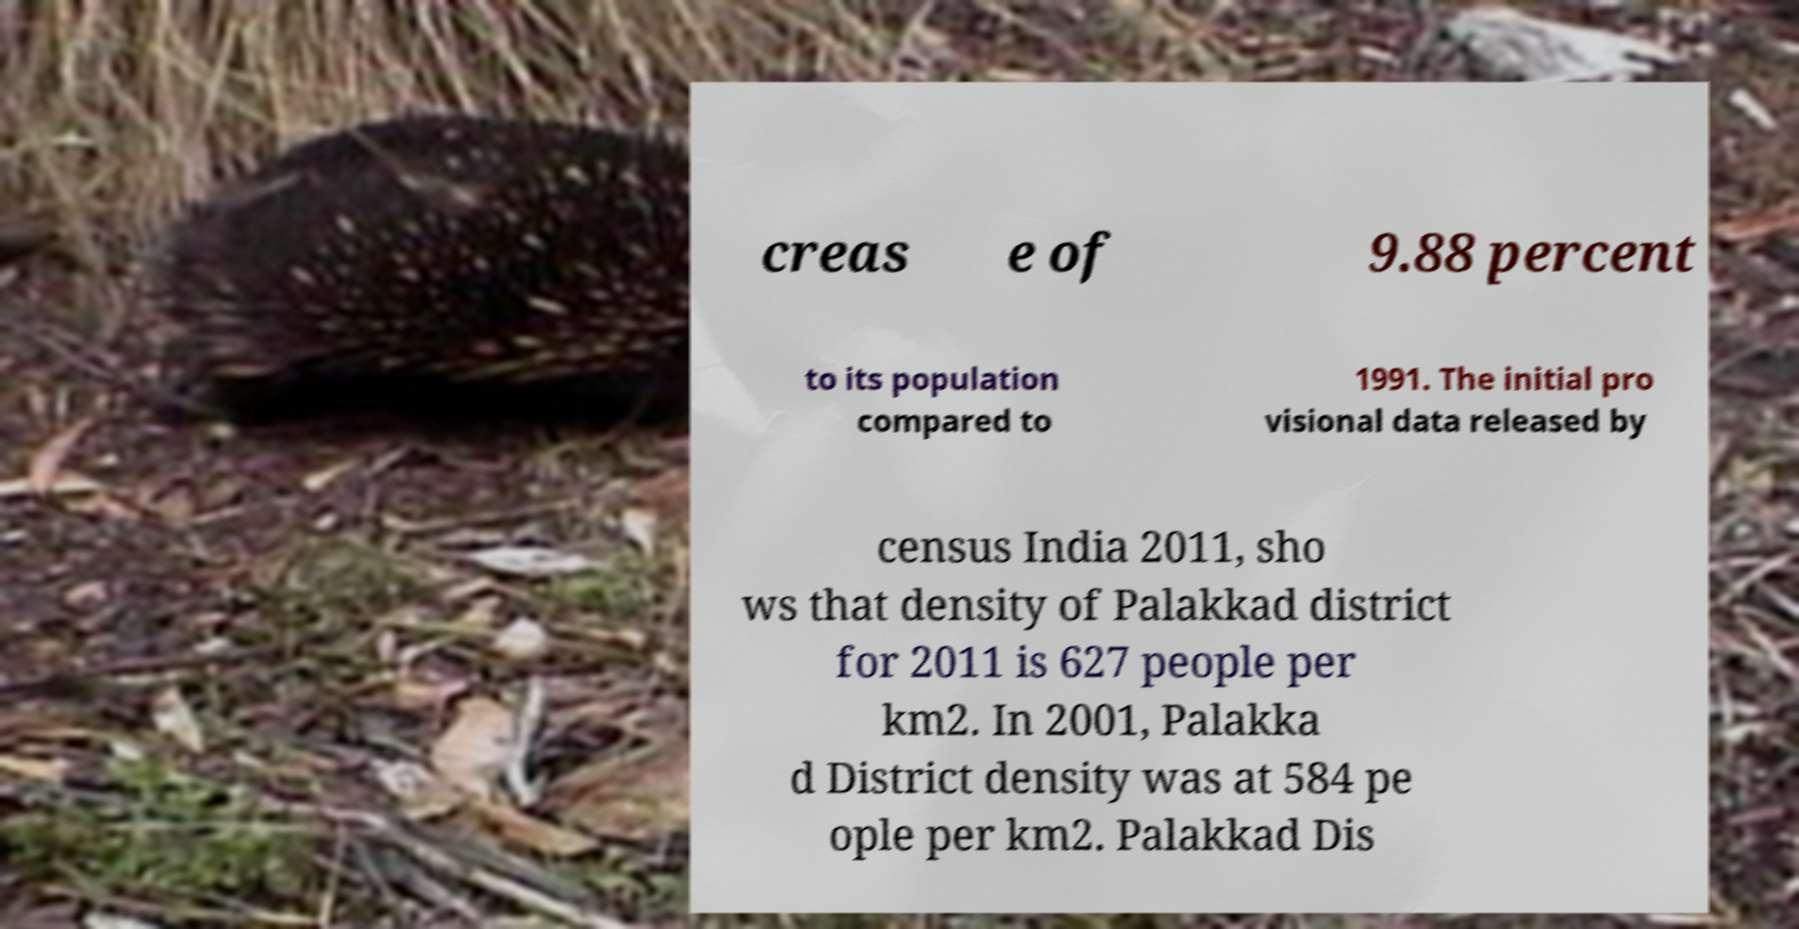There's text embedded in this image that I need extracted. Can you transcribe it verbatim? creas e of 9.88 percent to its population compared to 1991. The initial pro visional data released by census India 2011, sho ws that density of Palakkad district for 2011 is 627 people per km2. In 2001, Palakka d District density was at 584 pe ople per km2. Palakkad Dis 